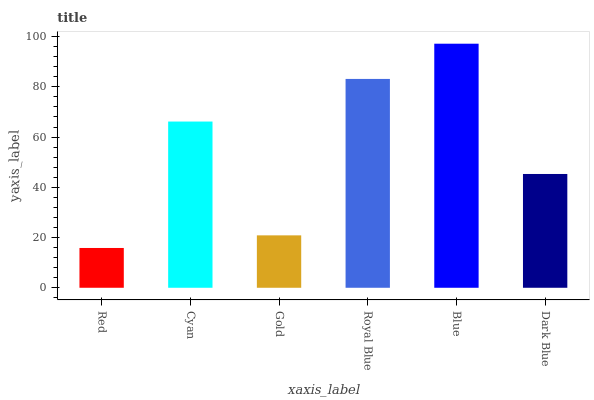Is Red the minimum?
Answer yes or no. Yes. Is Blue the maximum?
Answer yes or no. Yes. Is Cyan the minimum?
Answer yes or no. No. Is Cyan the maximum?
Answer yes or no. No. Is Cyan greater than Red?
Answer yes or no. Yes. Is Red less than Cyan?
Answer yes or no. Yes. Is Red greater than Cyan?
Answer yes or no. No. Is Cyan less than Red?
Answer yes or no. No. Is Cyan the high median?
Answer yes or no. Yes. Is Dark Blue the low median?
Answer yes or no. Yes. Is Dark Blue the high median?
Answer yes or no. No. Is Cyan the low median?
Answer yes or no. No. 